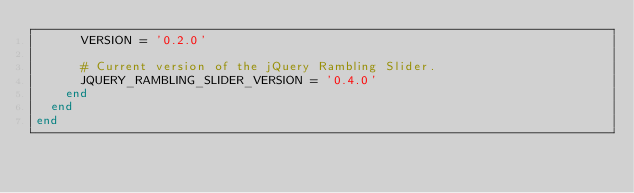Convert code to text. <code><loc_0><loc_0><loc_500><loc_500><_Ruby_>      VERSION = '0.2.0'

      # Current version of the jQuery Rambling Slider.
      JQUERY_RAMBLING_SLIDER_VERSION = '0.4.0'
    end
  end
end
</code> 